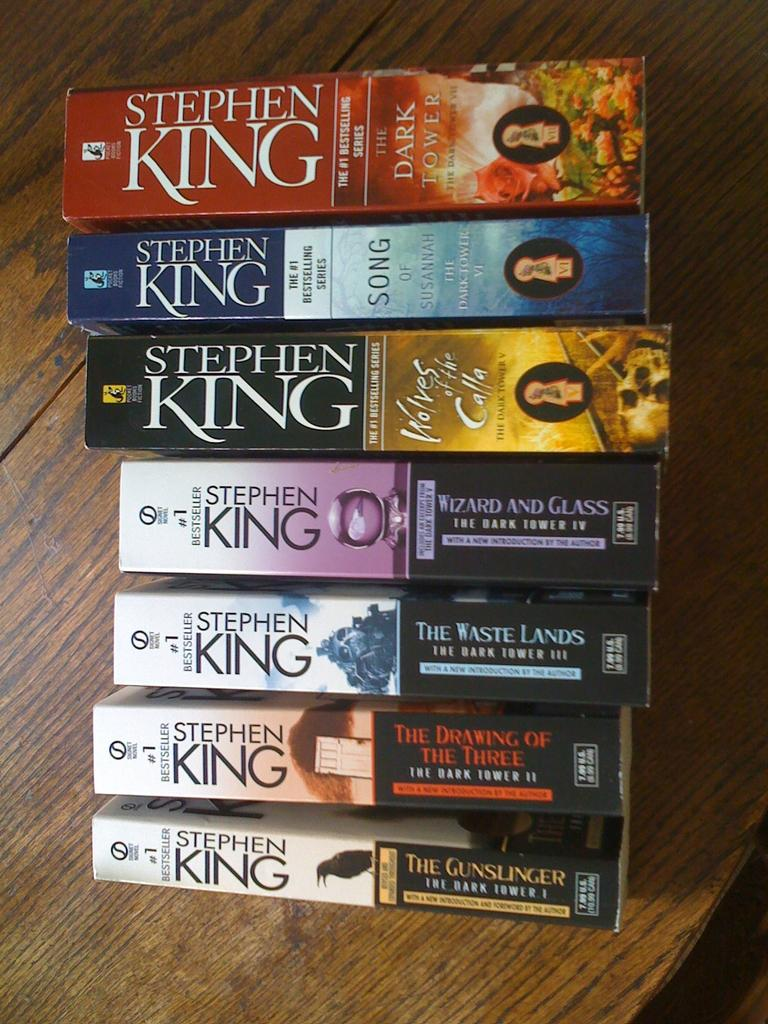<image>
Create a compact narrative representing the image presented. Boxes of Video Home System tapes based on Stephen King stories. 